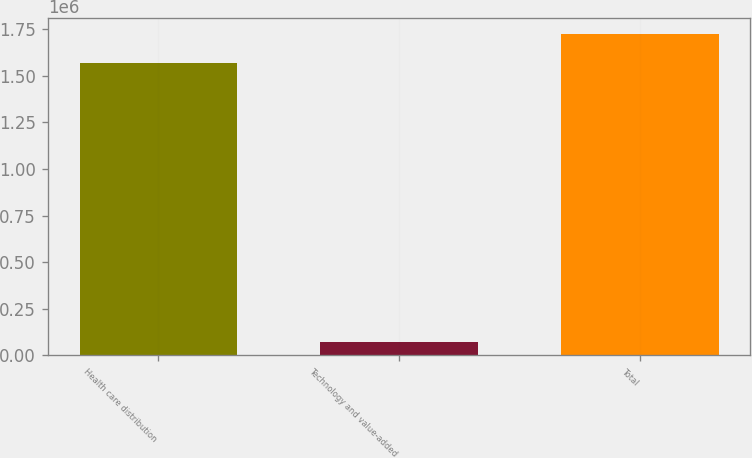<chart> <loc_0><loc_0><loc_500><loc_500><bar_chart><fcel>Health care distribution<fcel>Technology and value-added<fcel>Total<nl><fcel>1.56619e+06<fcel>71270<fcel>1.72281e+06<nl></chart> 